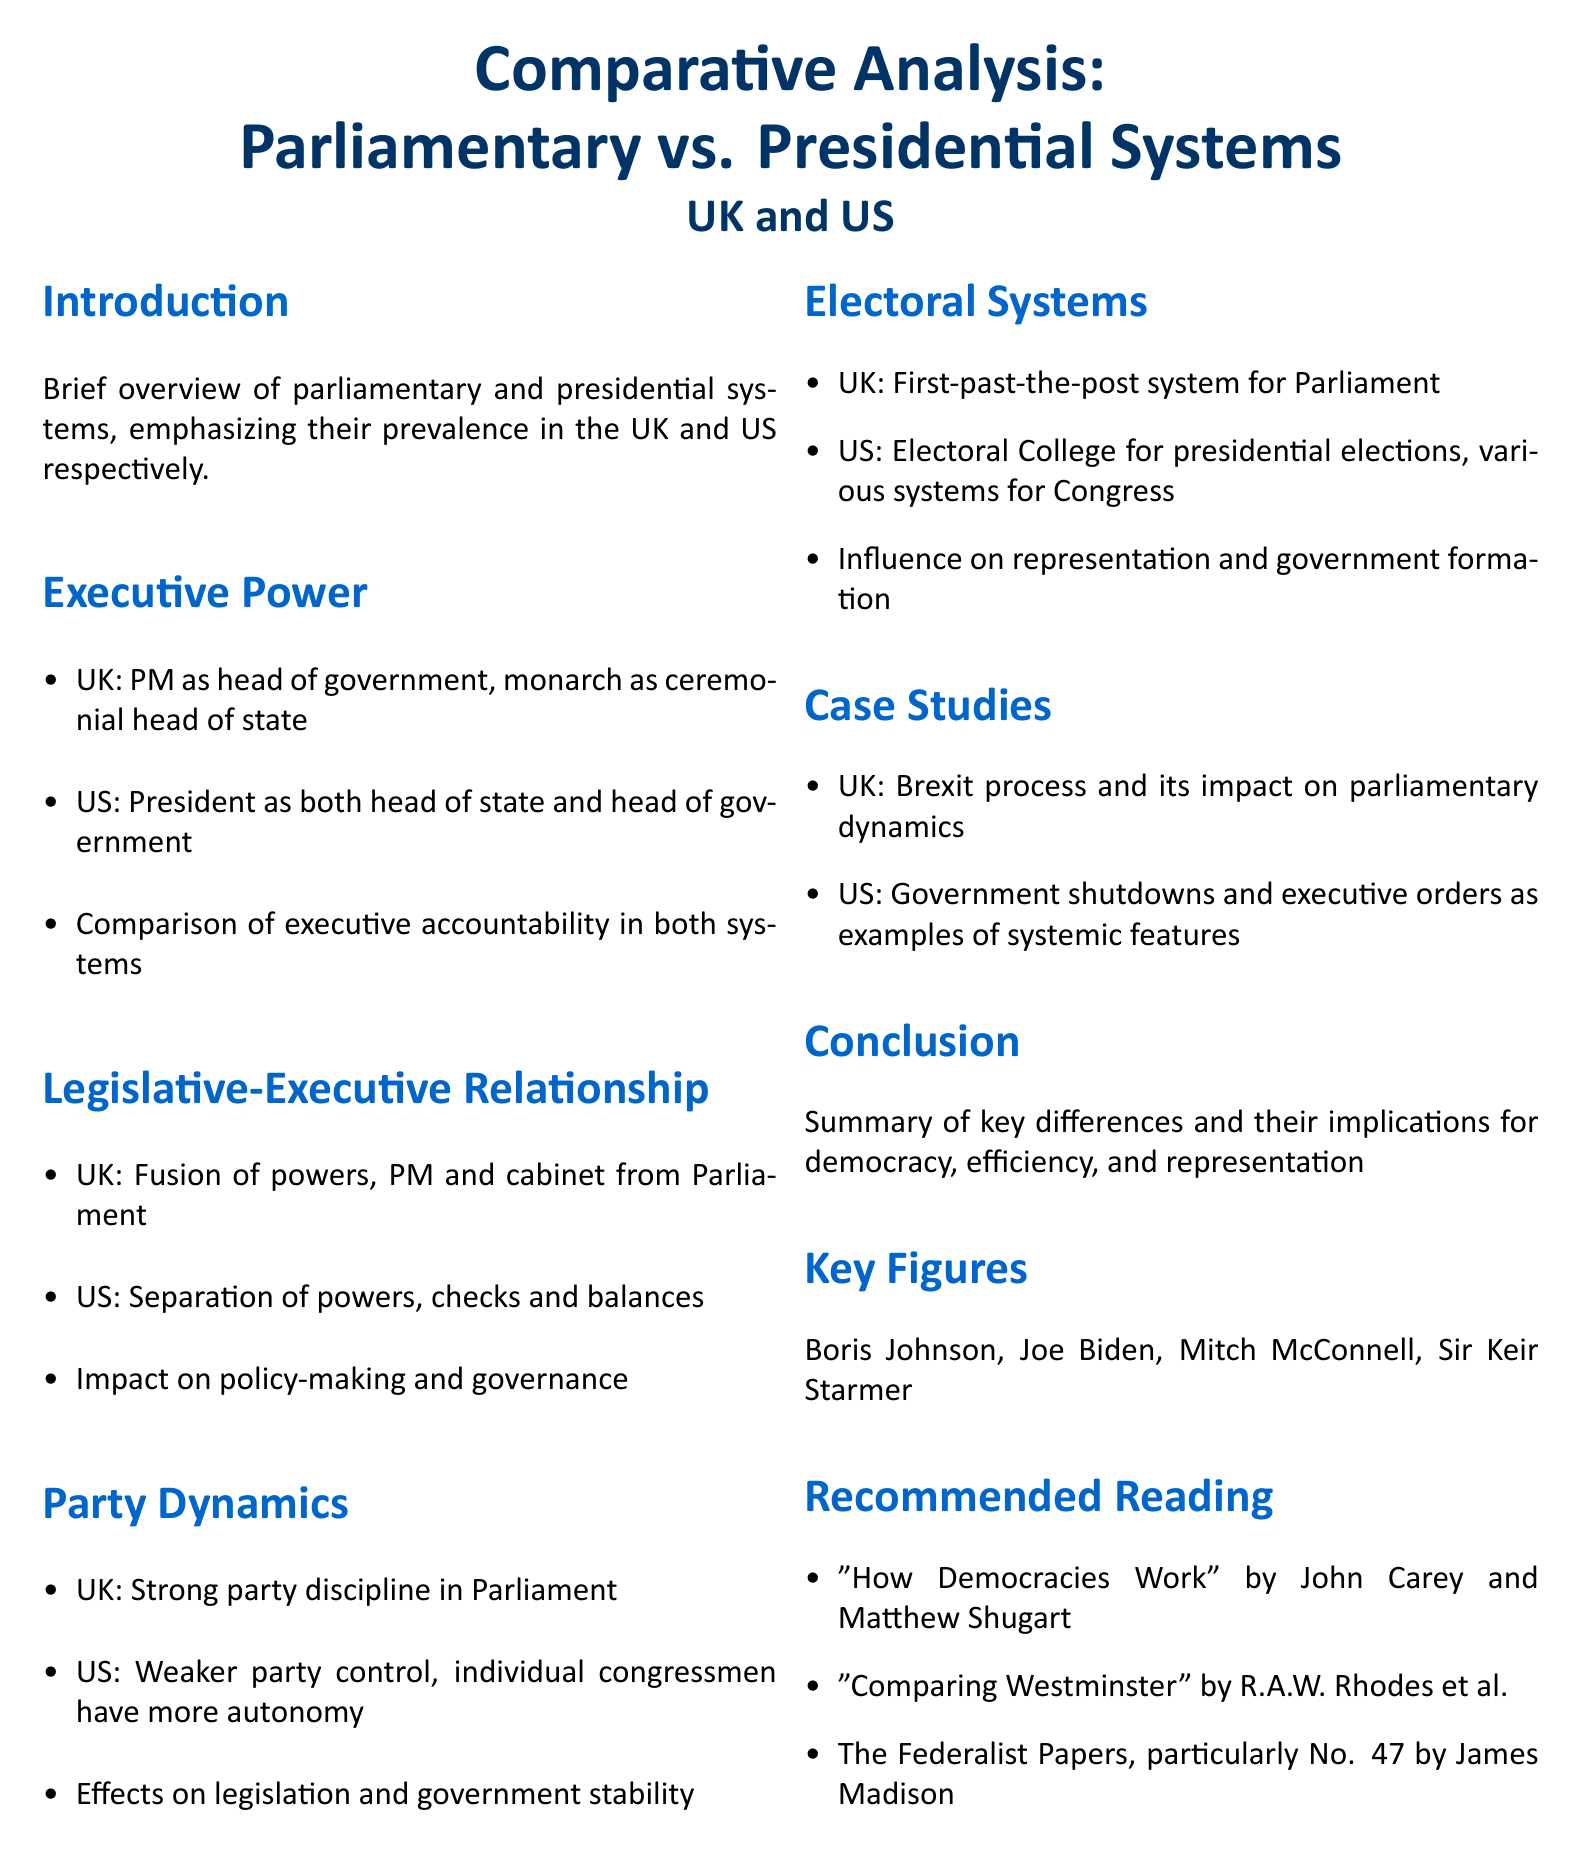What is the title of the document? The title of the document is presented at the beginning and indicates the subject of the analysis.
Answer: Comparative Analysis of Parliamentary vs. Presidential Systems: UK and US Who is the head of government in the UK? The document specifies the role of the Prime Minister in the UK, defining it as the head of government.
Answer: Prime Minister What type of executive power does the US system have? The document describes the US system where the President serves dual roles, which is a key feature of its governance.
Answer: Both head of state and head of government What electoral system is used for Parliament in the UK? The section on electoral systems outlines the specific method used in the UK for electing members of Parliament.
Answer: First-past-the-post What is a notable case study mentioned for the UK? The case studies section lists significant events that illustrate parliamentary dynamics in the UK.
Answer: Brexit process How does party control differ between the UK and the US? The document compares the strength of party discipline in the UK with the autonomy of individual congressmen in the US.
Answer: Strong party discipline in Parliament; weaker party control in US What is an example of a systemic feature in US politics? The document provides an example from US politics that reflects the implications of its presidential system on governance.
Answer: Government shutdowns Who authored "How Democracies Work"? The recommended reading section lists authors of suggested literature related to the document's subject.
Answer: John Carey and Matthew Shugart 